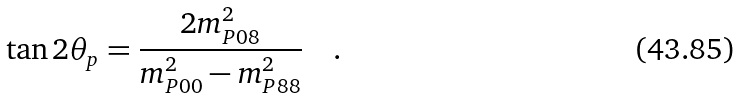<formula> <loc_0><loc_0><loc_500><loc_500>\tan 2 \theta _ { p } = \frac { 2 m _ { P 0 8 } ^ { 2 } } { m _ { P 0 0 } ^ { 2 } - m _ { P 8 8 } ^ { 2 } } \quad .</formula> 